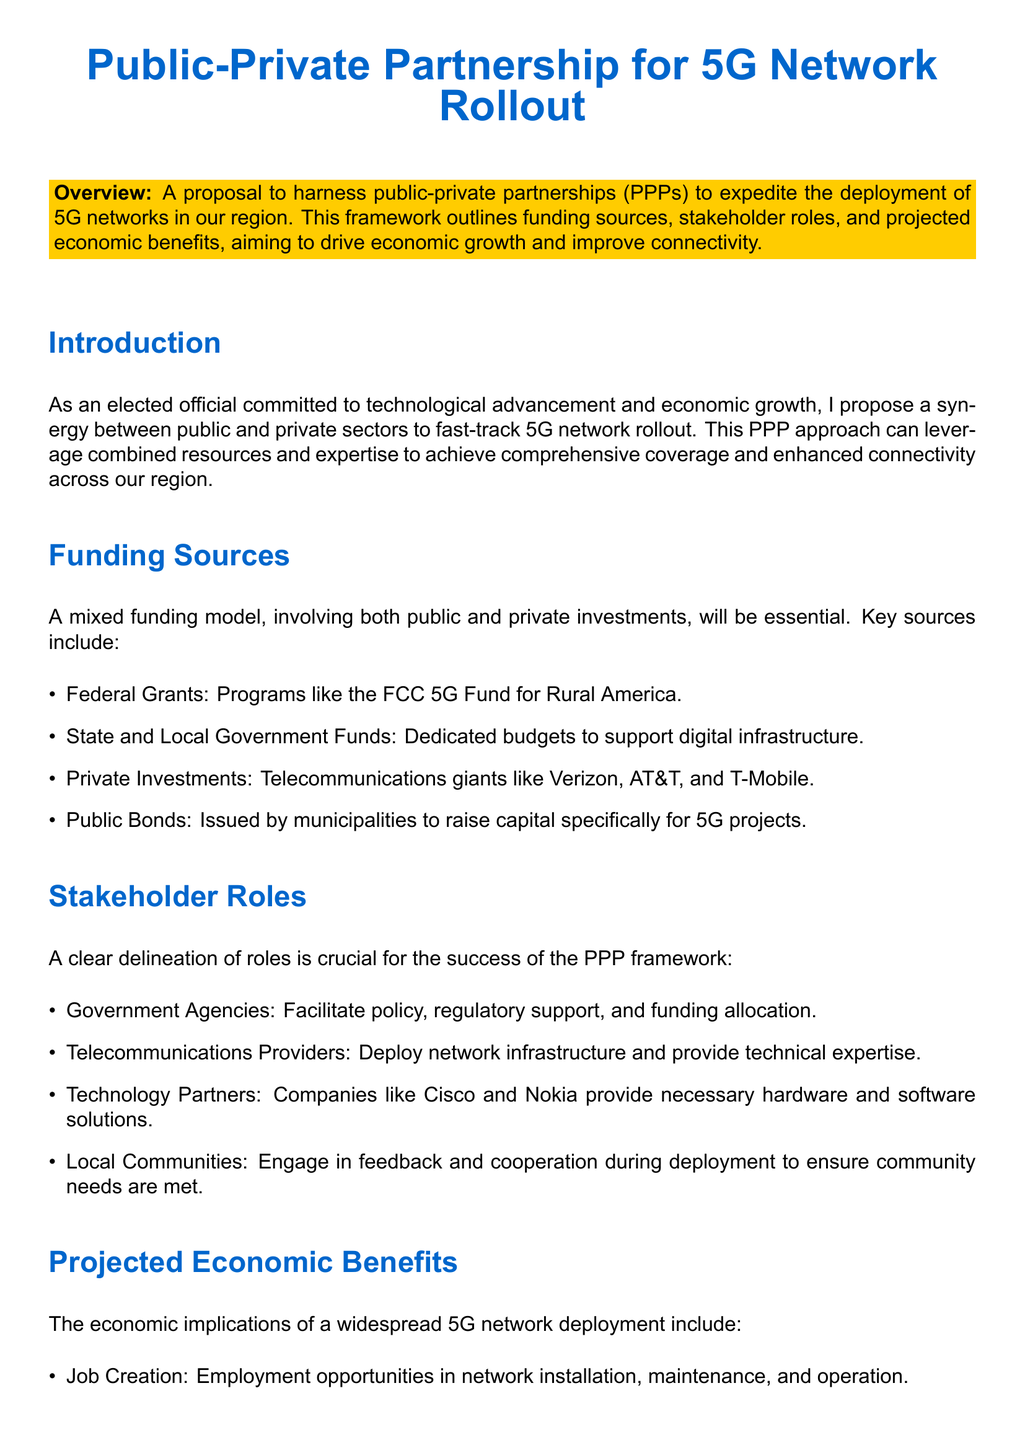what is the focus of the proposal? The proposal focuses on harnessing public-private partnerships to expedite 5G network deployment.
Answer: Public-Private Partnerships for 5G Network Rollout which Federal program is mentioned for funding? The document lists the FCC 5G Fund for Rural America as a funding source.
Answer: FCC 5G Fund for Rural America who are the main telecommunications providers involved? The document names Verizon, AT&T, and T-Mobile as key private investors.
Answer: Verizon, AT&T, T-Mobile what sector will benefit from enhanced connectivity according to the projected economic benefits? The document mentions local businesses as a sector that will grow from enhanced connectivity.
Answer: Business Growth what role do government agencies play in this framework? Government agencies facilitate policy, regulatory support, and funding allocation.
Answer: Facilitate policy, regulatory support, and funding allocation which type of infrastructure is mentioned as a benefit of a widespread 5G network? The document indicates that smart infrastructure is one of the projected economic benefits.
Answer: Smart Infrastructure how many key funding sources are listed in the document? The document identifies four key funding sources for the 5G network rollout.
Answer: Four what type of partnerships does the proposal emphasize? The document emphasizes a collaborative framework involving both public and private sectors.
Answer: Collaborative framework which technology companies are mentioned as partners for the deployment? The document mentions Cisco and Nokia as technology partners providing hardware and software solutions.
Answer: Cisco and Nokia 